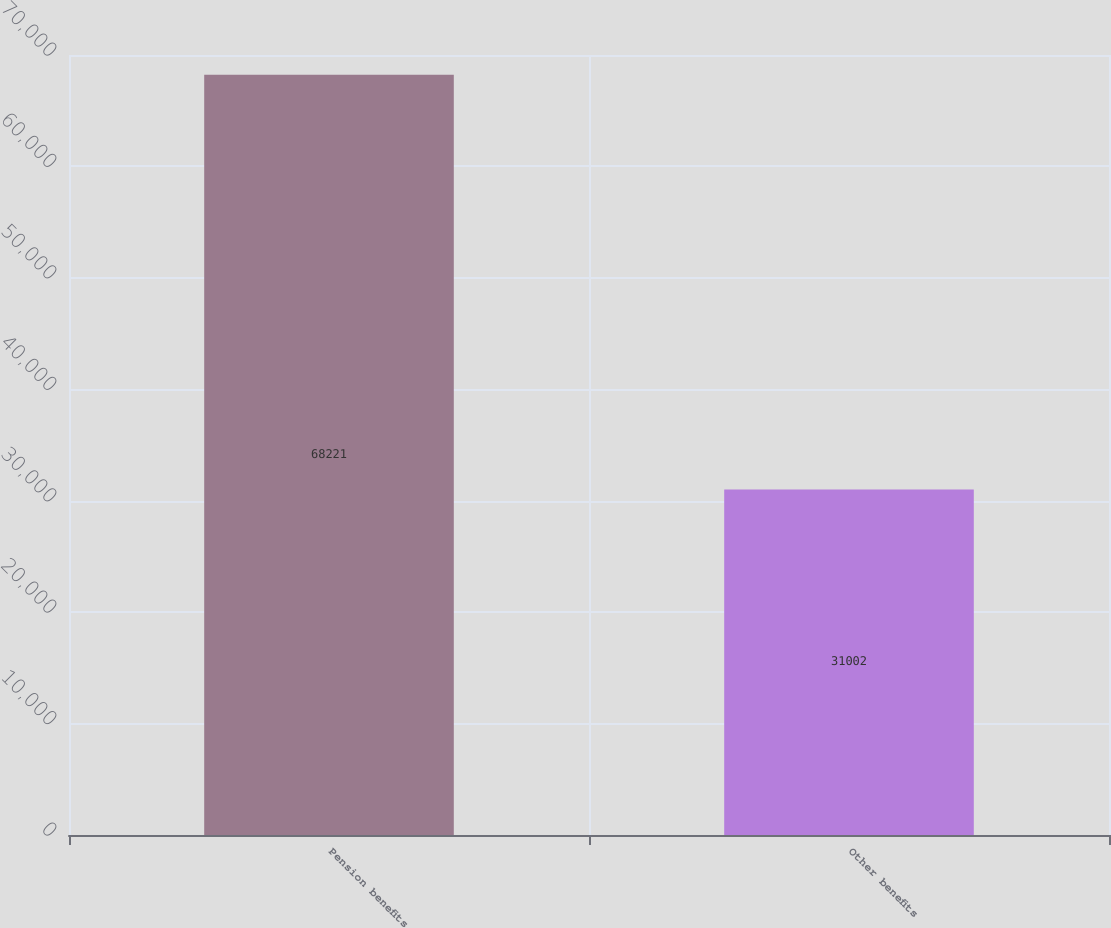Convert chart to OTSL. <chart><loc_0><loc_0><loc_500><loc_500><bar_chart><fcel>Pension benefits<fcel>Other benefits<nl><fcel>68221<fcel>31002<nl></chart> 